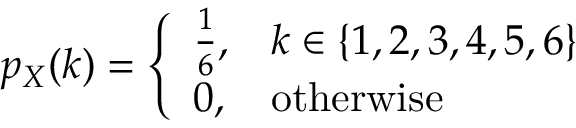<formula> <loc_0><loc_0><loc_500><loc_500>p _ { X } ( k ) = { \left \{ \begin{array} { l l } { { \frac { 1 } { 6 } } , } & { k \in \{ 1 , 2 , 3 , 4 , 5 , 6 \} } \\ { 0 , } & { o t h e r w i s e } \end{array} }</formula> 